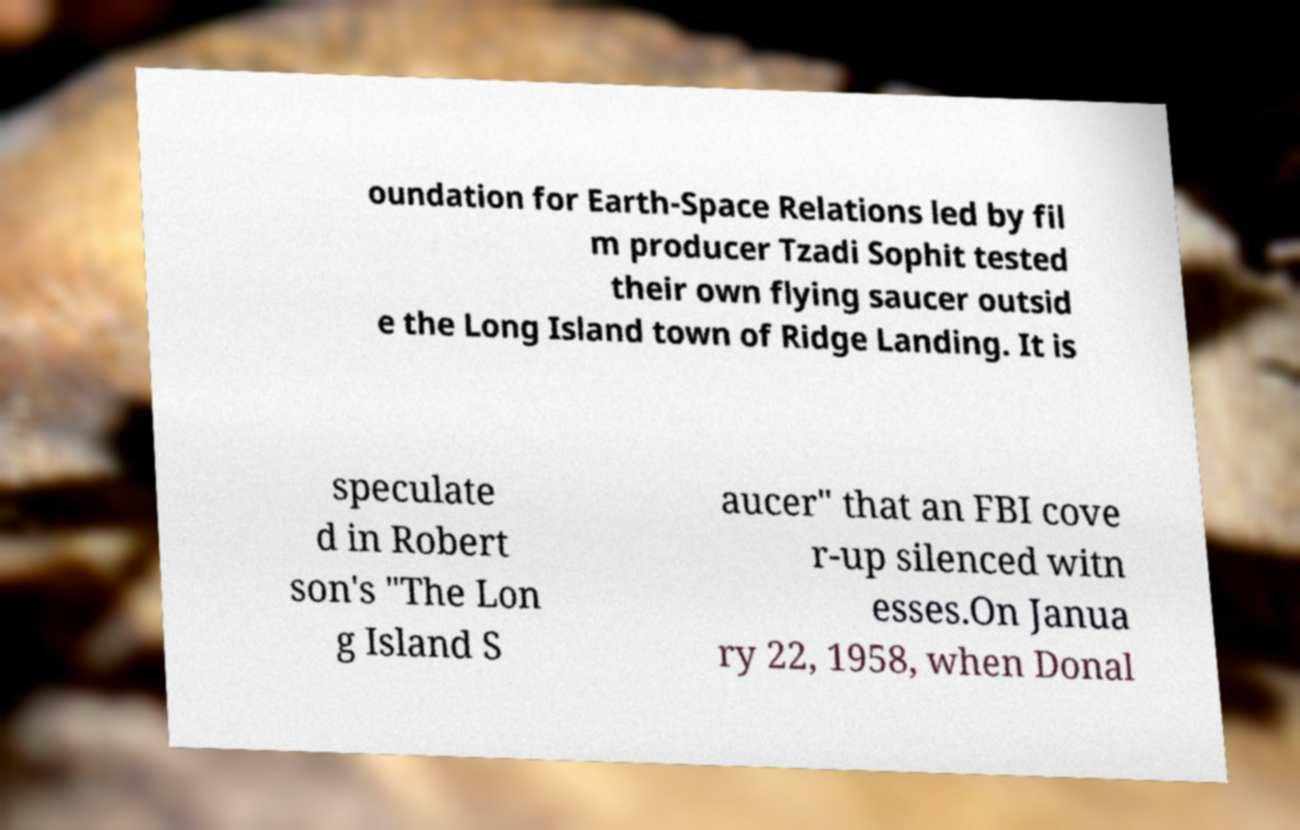There's text embedded in this image that I need extracted. Can you transcribe it verbatim? oundation for Earth-Space Relations led by fil m producer Tzadi Sophit tested their own flying saucer outsid e the Long Island town of Ridge Landing. It is speculate d in Robert son's "The Lon g Island S aucer" that an FBI cove r-up silenced witn esses.On Janua ry 22, 1958, when Donal 